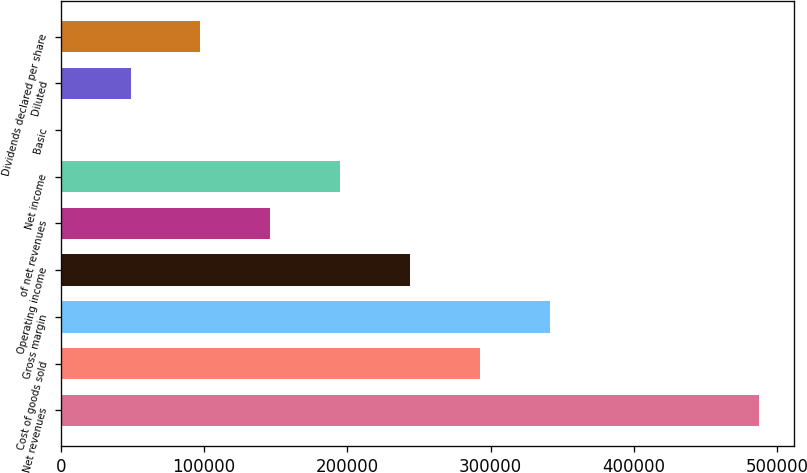Convert chart to OTSL. <chart><loc_0><loc_0><loc_500><loc_500><bar_chart><fcel>Net revenues<fcel>Cost of goods sold<fcel>Gross margin<fcel>Operating income<fcel>of net revenues<fcel>Net income<fcel>Basic<fcel>Diluted<fcel>Dividends declared per share<nl><fcel>487410<fcel>292446<fcel>341187<fcel>243705<fcel>146223<fcel>194964<fcel>0.19<fcel>48741.2<fcel>97482.1<nl></chart> 